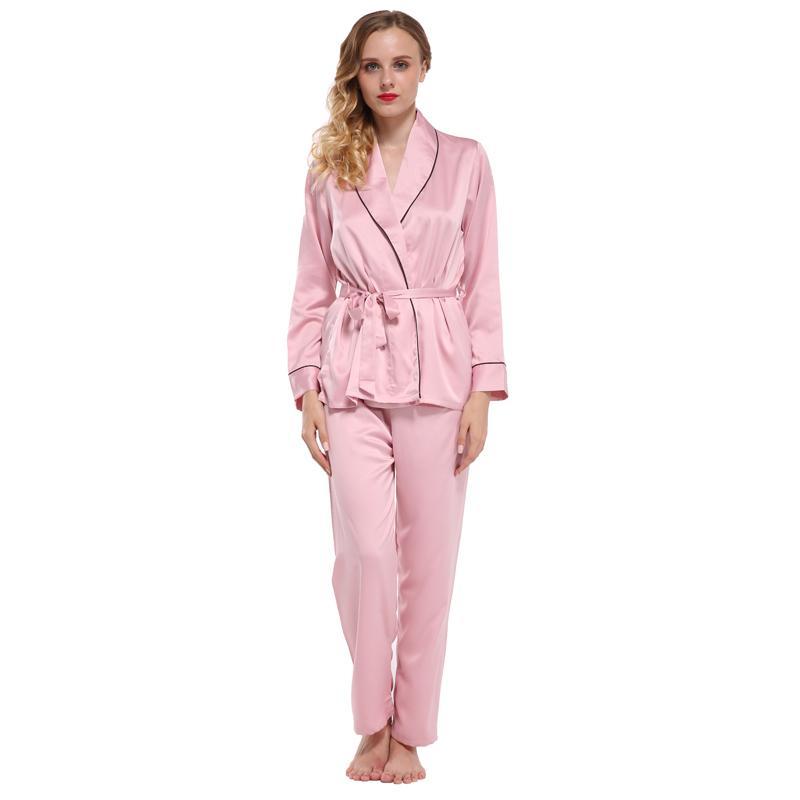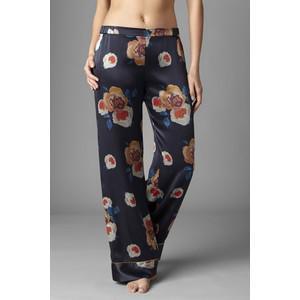The first image is the image on the left, the second image is the image on the right. Considering the images on both sides, is "The left image shows a woman modeling matching pajama top and bottom." valid? Answer yes or no. Yes. 